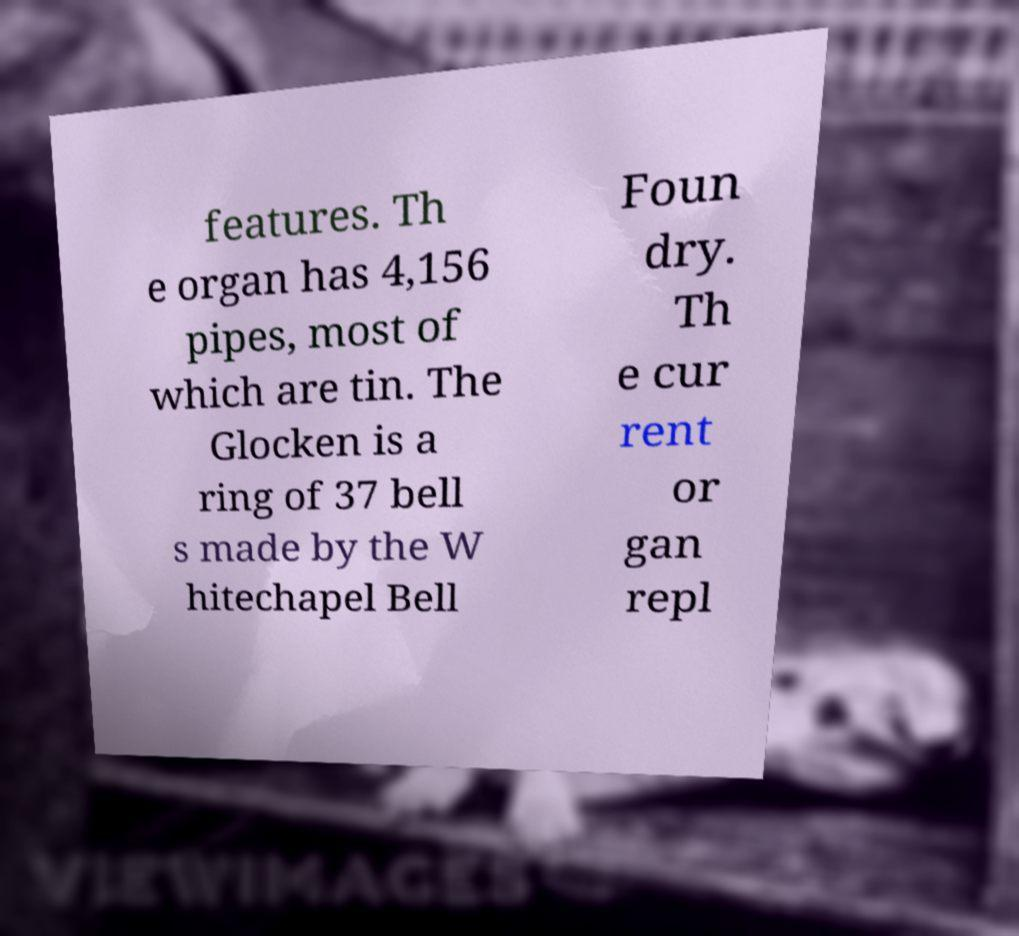Could you assist in decoding the text presented in this image and type it out clearly? features. Th e organ has 4,156 pipes, most of which are tin. The Glocken is a ring of 37 bell s made by the W hitechapel Bell Foun dry. Th e cur rent or gan repl 